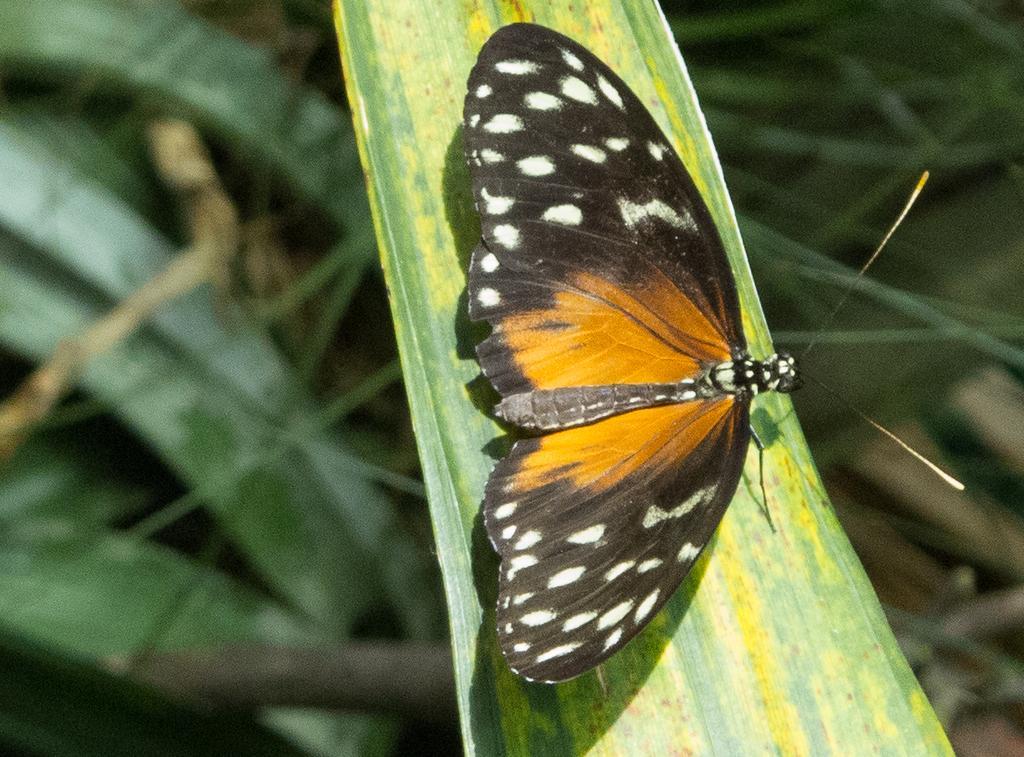Please provide a concise description of this image. In this picture we can see a butterfly on the grass. 